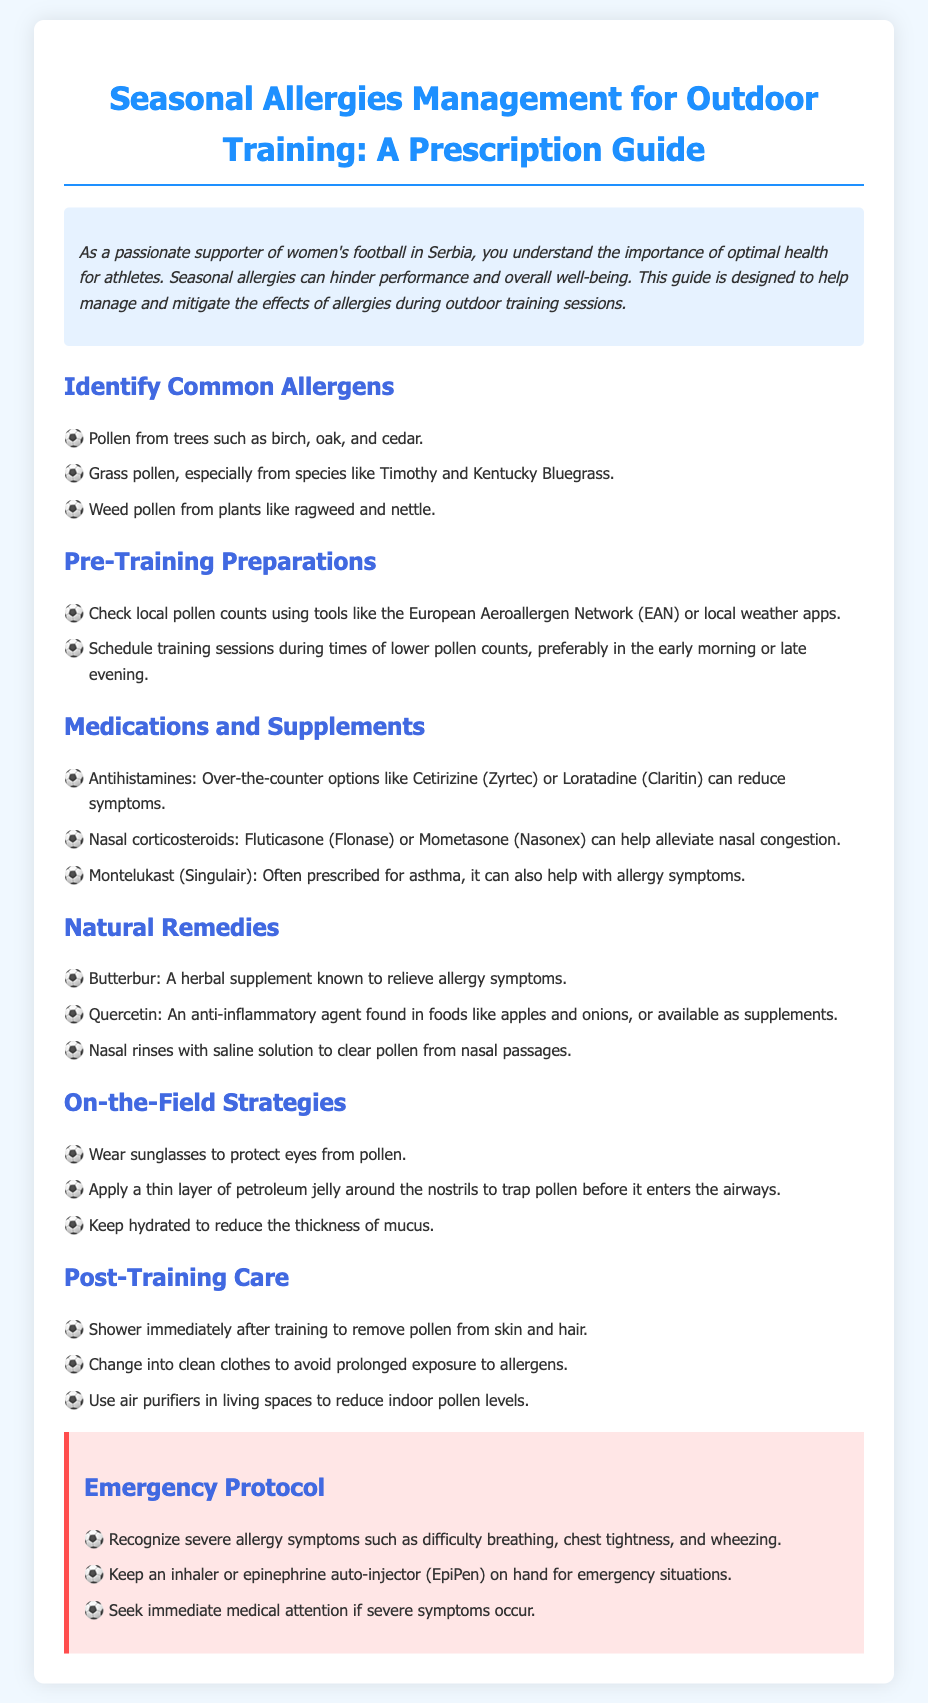What are common allergens for outdoor training? The document lists common allergens that can affect outdoor training, such as pollen from trees, grass, and weeds.
Answer: Pollen from trees, grass, and weeds When should training sessions be scheduled to minimize allergy impact? The guide suggests specific times of day to schedule training sessions to avoid high pollen counts.
Answer: Early morning or late evening Name an over-the-counter antihistamine mentioned. The document provides examples of medications, including specific names for over-the-counter antihistamines.
Answer: Cetirizine (Zyrtec) What is a natural remedy recommended in the document? The guide includes suggestions for natural remedies that can help alleviate allergy symptoms.
Answer: Butterbur What should you do immediately after training to reduce allergen exposure? Post-training care advice in the guide includes specific actions to reduce allergen exposure after training.
Answer: Shower immediately after training What emergency action should be taken for severe allergy symptoms? The document outlines essential emergency protocols for managing severe allergy symptoms.
Answer: Seek immediate medical attention Which organization can be used to check local pollen counts? The document mentions tools and organizations for checking pollen counts, providing specific examples.
Answer: European Aeroallergen Network (EAN) How can hydration help during outdoor training? The guide provides reasons for staying hydrated as a method to assist with allergy management.
Answer: Reduce the thickness of mucus 